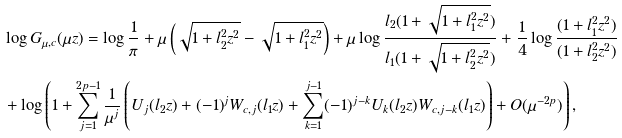<formula> <loc_0><loc_0><loc_500><loc_500>& \log G _ { \mu , c } ( \mu z ) = \log \frac { 1 } { \pi } + \mu \left ( \sqrt { 1 + l _ { 2 } ^ { 2 } z ^ { 2 } } - \sqrt { 1 + l _ { 1 } ^ { 2 } z ^ { 2 } } \right ) + \mu \log \frac { l _ { 2 } ( 1 + \sqrt { 1 + l _ { 1 } ^ { 2 } z ^ { 2 } } ) } { l _ { 1 } ( 1 + \sqrt { 1 + l _ { 2 } ^ { 2 } z ^ { 2 } } ) } + \frac { 1 } { 4 } \log \frac { ( 1 + l _ { 1 } ^ { 2 } z ^ { 2 } ) } { ( 1 + l _ { 2 } ^ { 2 } z ^ { 2 } ) } \\ & + \log \left ( 1 + \sum _ { j = 1 } ^ { 2 p - 1 } \frac { 1 } { \mu ^ { j } } \left ( U _ { j } ( l _ { 2 } z ) + ( - 1 ) ^ { j } W _ { c , j } ( l _ { 1 } z ) + \sum _ { k = 1 } ^ { j - 1 } ( - 1 ) ^ { j - k } U _ { k } ( l _ { 2 } z ) W _ { c , j - k } ( l _ { 1 } z ) \right ) + O ( \mu ^ { - 2 p } ) \right ) ,</formula> 